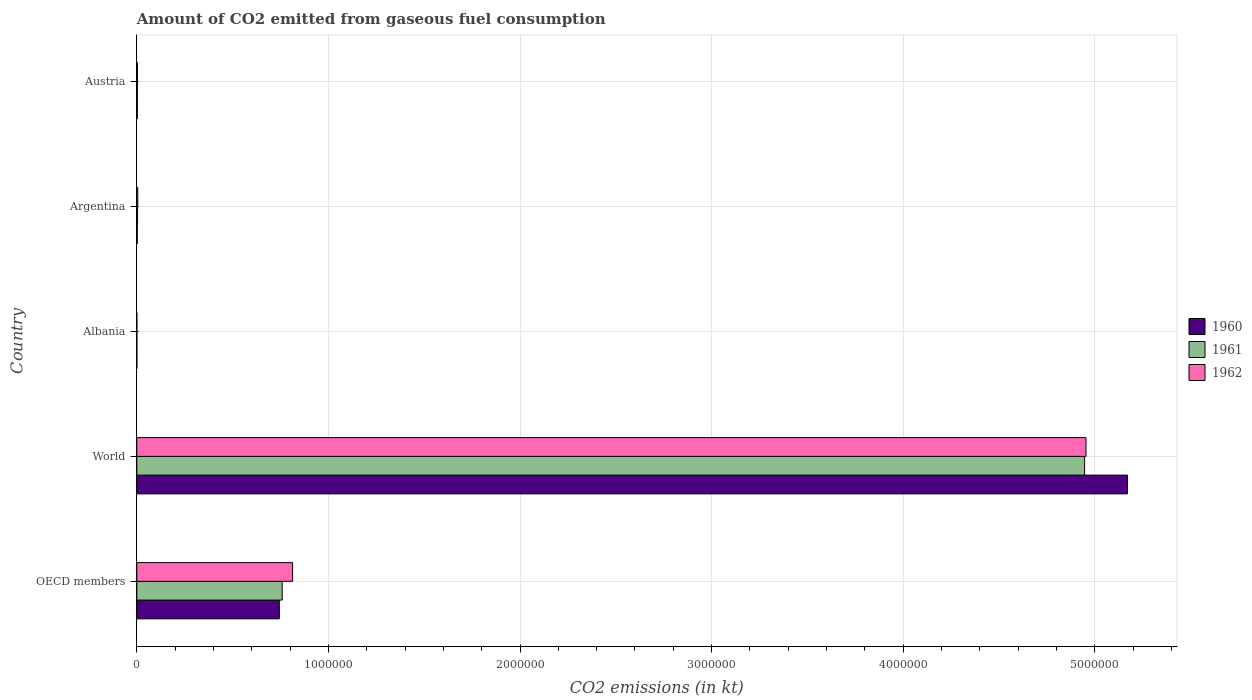Are the number of bars on each tick of the Y-axis equal?
Your answer should be very brief. Yes. In how many cases, is the number of bars for a given country not equal to the number of legend labels?
Your answer should be compact. 0. What is the amount of CO2 emitted in 1960 in Argentina?
Provide a short and direct response. 2365.22. Across all countries, what is the maximum amount of CO2 emitted in 1960?
Give a very brief answer. 5.17e+06. Across all countries, what is the minimum amount of CO2 emitted in 1961?
Your answer should be compact. 84.34. In which country was the amount of CO2 emitted in 1960 maximum?
Ensure brevity in your answer.  World. In which country was the amount of CO2 emitted in 1961 minimum?
Provide a succinct answer. Albania. What is the total amount of CO2 emitted in 1962 in the graph?
Offer a very short reply. 5.78e+06. What is the difference between the amount of CO2 emitted in 1962 in Argentina and that in Austria?
Provide a short and direct response. 1870.17. What is the difference between the amount of CO2 emitted in 1960 in Argentina and the amount of CO2 emitted in 1962 in Austria?
Keep it short and to the point. -876.41. What is the average amount of CO2 emitted in 1960 per country?
Provide a short and direct response. 1.18e+06. What is the difference between the amount of CO2 emitted in 1961 and amount of CO2 emitted in 1962 in Austria?
Your answer should be very brief. -150.35. What is the ratio of the amount of CO2 emitted in 1961 in Albania to that in Austria?
Give a very brief answer. 0.03. Is the amount of CO2 emitted in 1960 in Argentina less than that in World?
Ensure brevity in your answer.  Yes. What is the difference between the highest and the second highest amount of CO2 emitted in 1962?
Provide a succinct answer. 4.14e+06. What is the difference between the highest and the lowest amount of CO2 emitted in 1961?
Your response must be concise. 4.95e+06. What does the 1st bar from the top in World represents?
Make the answer very short. 1962. How many bars are there?
Your response must be concise. 15. Are all the bars in the graph horizontal?
Give a very brief answer. Yes. Are the values on the major ticks of X-axis written in scientific E-notation?
Offer a very short reply. No. Does the graph contain any zero values?
Give a very brief answer. No. Does the graph contain grids?
Offer a terse response. Yes. Where does the legend appear in the graph?
Ensure brevity in your answer.  Center right. How are the legend labels stacked?
Keep it short and to the point. Vertical. What is the title of the graph?
Ensure brevity in your answer.  Amount of CO2 emitted from gaseous fuel consumption. Does "1995" appear as one of the legend labels in the graph?
Ensure brevity in your answer.  No. What is the label or title of the X-axis?
Your response must be concise. CO2 emissions (in kt). What is the label or title of the Y-axis?
Provide a succinct answer. Country. What is the CO2 emissions (in kt) of 1960 in OECD members?
Offer a very short reply. 7.44e+05. What is the CO2 emissions (in kt) in 1961 in OECD members?
Provide a short and direct response. 7.59e+05. What is the CO2 emissions (in kt) in 1962 in OECD members?
Offer a terse response. 8.13e+05. What is the CO2 emissions (in kt) of 1960 in World?
Keep it short and to the point. 5.17e+06. What is the CO2 emissions (in kt) of 1961 in World?
Your answer should be compact. 4.95e+06. What is the CO2 emissions (in kt) of 1962 in World?
Make the answer very short. 4.95e+06. What is the CO2 emissions (in kt) of 1960 in Albania?
Your answer should be compact. 84.34. What is the CO2 emissions (in kt) in 1961 in Albania?
Keep it short and to the point. 84.34. What is the CO2 emissions (in kt) in 1962 in Albania?
Your answer should be very brief. 84.34. What is the CO2 emissions (in kt) of 1960 in Argentina?
Provide a short and direct response. 2365.22. What is the CO2 emissions (in kt) in 1961 in Argentina?
Your answer should be compact. 4033.7. What is the CO2 emissions (in kt) of 1962 in Argentina?
Your answer should be compact. 5111.8. What is the CO2 emissions (in kt) of 1960 in Austria?
Provide a short and direct response. 2922.6. What is the CO2 emissions (in kt) in 1961 in Austria?
Make the answer very short. 3091.28. What is the CO2 emissions (in kt) of 1962 in Austria?
Your answer should be very brief. 3241.63. Across all countries, what is the maximum CO2 emissions (in kt) of 1960?
Offer a very short reply. 5.17e+06. Across all countries, what is the maximum CO2 emissions (in kt) in 1961?
Make the answer very short. 4.95e+06. Across all countries, what is the maximum CO2 emissions (in kt) of 1962?
Offer a terse response. 4.95e+06. Across all countries, what is the minimum CO2 emissions (in kt) in 1960?
Your response must be concise. 84.34. Across all countries, what is the minimum CO2 emissions (in kt) in 1961?
Ensure brevity in your answer.  84.34. Across all countries, what is the minimum CO2 emissions (in kt) of 1962?
Your response must be concise. 84.34. What is the total CO2 emissions (in kt) in 1960 in the graph?
Give a very brief answer. 5.92e+06. What is the total CO2 emissions (in kt) of 1961 in the graph?
Give a very brief answer. 5.71e+06. What is the total CO2 emissions (in kt) in 1962 in the graph?
Give a very brief answer. 5.78e+06. What is the difference between the CO2 emissions (in kt) of 1960 in OECD members and that in World?
Ensure brevity in your answer.  -4.43e+06. What is the difference between the CO2 emissions (in kt) in 1961 in OECD members and that in World?
Make the answer very short. -4.19e+06. What is the difference between the CO2 emissions (in kt) in 1962 in OECD members and that in World?
Provide a short and direct response. -4.14e+06. What is the difference between the CO2 emissions (in kt) of 1960 in OECD members and that in Albania?
Offer a very short reply. 7.44e+05. What is the difference between the CO2 emissions (in kt) in 1961 in OECD members and that in Albania?
Provide a short and direct response. 7.59e+05. What is the difference between the CO2 emissions (in kt) in 1962 in OECD members and that in Albania?
Offer a very short reply. 8.13e+05. What is the difference between the CO2 emissions (in kt) in 1960 in OECD members and that in Argentina?
Your response must be concise. 7.42e+05. What is the difference between the CO2 emissions (in kt) in 1961 in OECD members and that in Argentina?
Give a very brief answer. 7.55e+05. What is the difference between the CO2 emissions (in kt) in 1962 in OECD members and that in Argentina?
Make the answer very short. 8.08e+05. What is the difference between the CO2 emissions (in kt) in 1960 in OECD members and that in Austria?
Provide a short and direct response. 7.41e+05. What is the difference between the CO2 emissions (in kt) in 1961 in OECD members and that in Austria?
Offer a very short reply. 7.56e+05. What is the difference between the CO2 emissions (in kt) of 1962 in OECD members and that in Austria?
Your answer should be compact. 8.10e+05. What is the difference between the CO2 emissions (in kt) in 1960 in World and that in Albania?
Provide a short and direct response. 5.17e+06. What is the difference between the CO2 emissions (in kt) in 1961 in World and that in Albania?
Offer a terse response. 4.95e+06. What is the difference between the CO2 emissions (in kt) of 1962 in World and that in Albania?
Provide a short and direct response. 4.95e+06. What is the difference between the CO2 emissions (in kt) in 1960 in World and that in Argentina?
Offer a very short reply. 5.17e+06. What is the difference between the CO2 emissions (in kt) of 1961 in World and that in Argentina?
Provide a short and direct response. 4.94e+06. What is the difference between the CO2 emissions (in kt) of 1962 in World and that in Argentina?
Your answer should be compact. 4.95e+06. What is the difference between the CO2 emissions (in kt) in 1960 in World and that in Austria?
Provide a succinct answer. 5.17e+06. What is the difference between the CO2 emissions (in kt) of 1961 in World and that in Austria?
Keep it short and to the point. 4.94e+06. What is the difference between the CO2 emissions (in kt) of 1962 in World and that in Austria?
Ensure brevity in your answer.  4.95e+06. What is the difference between the CO2 emissions (in kt) in 1960 in Albania and that in Argentina?
Provide a short and direct response. -2280.87. What is the difference between the CO2 emissions (in kt) of 1961 in Albania and that in Argentina?
Offer a very short reply. -3949.36. What is the difference between the CO2 emissions (in kt) in 1962 in Albania and that in Argentina?
Make the answer very short. -5027.46. What is the difference between the CO2 emissions (in kt) in 1960 in Albania and that in Austria?
Give a very brief answer. -2838.26. What is the difference between the CO2 emissions (in kt) of 1961 in Albania and that in Austria?
Your response must be concise. -3006.94. What is the difference between the CO2 emissions (in kt) of 1962 in Albania and that in Austria?
Your response must be concise. -3157.29. What is the difference between the CO2 emissions (in kt) of 1960 in Argentina and that in Austria?
Provide a short and direct response. -557.38. What is the difference between the CO2 emissions (in kt) of 1961 in Argentina and that in Austria?
Offer a very short reply. 942.42. What is the difference between the CO2 emissions (in kt) in 1962 in Argentina and that in Austria?
Keep it short and to the point. 1870.17. What is the difference between the CO2 emissions (in kt) in 1960 in OECD members and the CO2 emissions (in kt) in 1961 in World?
Offer a very short reply. -4.20e+06. What is the difference between the CO2 emissions (in kt) of 1960 in OECD members and the CO2 emissions (in kt) of 1962 in World?
Offer a terse response. -4.21e+06. What is the difference between the CO2 emissions (in kt) in 1961 in OECD members and the CO2 emissions (in kt) in 1962 in World?
Make the answer very short. -4.20e+06. What is the difference between the CO2 emissions (in kt) of 1960 in OECD members and the CO2 emissions (in kt) of 1961 in Albania?
Offer a terse response. 7.44e+05. What is the difference between the CO2 emissions (in kt) in 1960 in OECD members and the CO2 emissions (in kt) in 1962 in Albania?
Your answer should be very brief. 7.44e+05. What is the difference between the CO2 emissions (in kt) in 1961 in OECD members and the CO2 emissions (in kt) in 1962 in Albania?
Make the answer very short. 7.59e+05. What is the difference between the CO2 emissions (in kt) of 1960 in OECD members and the CO2 emissions (in kt) of 1961 in Argentina?
Provide a succinct answer. 7.40e+05. What is the difference between the CO2 emissions (in kt) of 1960 in OECD members and the CO2 emissions (in kt) of 1962 in Argentina?
Provide a succinct answer. 7.39e+05. What is the difference between the CO2 emissions (in kt) in 1961 in OECD members and the CO2 emissions (in kt) in 1962 in Argentina?
Keep it short and to the point. 7.54e+05. What is the difference between the CO2 emissions (in kt) of 1960 in OECD members and the CO2 emissions (in kt) of 1961 in Austria?
Your answer should be very brief. 7.41e+05. What is the difference between the CO2 emissions (in kt) in 1960 in OECD members and the CO2 emissions (in kt) in 1962 in Austria?
Give a very brief answer. 7.41e+05. What is the difference between the CO2 emissions (in kt) in 1961 in OECD members and the CO2 emissions (in kt) in 1962 in Austria?
Provide a succinct answer. 7.56e+05. What is the difference between the CO2 emissions (in kt) in 1960 in World and the CO2 emissions (in kt) in 1961 in Albania?
Your answer should be compact. 5.17e+06. What is the difference between the CO2 emissions (in kt) in 1960 in World and the CO2 emissions (in kt) in 1962 in Albania?
Provide a short and direct response. 5.17e+06. What is the difference between the CO2 emissions (in kt) of 1961 in World and the CO2 emissions (in kt) of 1962 in Albania?
Your answer should be compact. 4.95e+06. What is the difference between the CO2 emissions (in kt) of 1960 in World and the CO2 emissions (in kt) of 1961 in Argentina?
Your response must be concise. 5.17e+06. What is the difference between the CO2 emissions (in kt) of 1960 in World and the CO2 emissions (in kt) of 1962 in Argentina?
Your answer should be very brief. 5.17e+06. What is the difference between the CO2 emissions (in kt) in 1961 in World and the CO2 emissions (in kt) in 1962 in Argentina?
Keep it short and to the point. 4.94e+06. What is the difference between the CO2 emissions (in kt) of 1960 in World and the CO2 emissions (in kt) of 1961 in Austria?
Ensure brevity in your answer.  5.17e+06. What is the difference between the CO2 emissions (in kt) of 1960 in World and the CO2 emissions (in kt) of 1962 in Austria?
Give a very brief answer. 5.17e+06. What is the difference between the CO2 emissions (in kt) in 1961 in World and the CO2 emissions (in kt) in 1962 in Austria?
Offer a terse response. 4.94e+06. What is the difference between the CO2 emissions (in kt) of 1960 in Albania and the CO2 emissions (in kt) of 1961 in Argentina?
Your answer should be compact. -3949.36. What is the difference between the CO2 emissions (in kt) in 1960 in Albania and the CO2 emissions (in kt) in 1962 in Argentina?
Offer a terse response. -5027.46. What is the difference between the CO2 emissions (in kt) in 1961 in Albania and the CO2 emissions (in kt) in 1962 in Argentina?
Your answer should be compact. -5027.46. What is the difference between the CO2 emissions (in kt) of 1960 in Albania and the CO2 emissions (in kt) of 1961 in Austria?
Offer a terse response. -3006.94. What is the difference between the CO2 emissions (in kt) in 1960 in Albania and the CO2 emissions (in kt) in 1962 in Austria?
Provide a succinct answer. -3157.29. What is the difference between the CO2 emissions (in kt) in 1961 in Albania and the CO2 emissions (in kt) in 1962 in Austria?
Your response must be concise. -3157.29. What is the difference between the CO2 emissions (in kt) of 1960 in Argentina and the CO2 emissions (in kt) of 1961 in Austria?
Offer a very short reply. -726.07. What is the difference between the CO2 emissions (in kt) in 1960 in Argentina and the CO2 emissions (in kt) in 1962 in Austria?
Make the answer very short. -876.41. What is the difference between the CO2 emissions (in kt) of 1961 in Argentina and the CO2 emissions (in kt) of 1962 in Austria?
Give a very brief answer. 792.07. What is the average CO2 emissions (in kt) of 1960 per country?
Offer a very short reply. 1.18e+06. What is the average CO2 emissions (in kt) in 1961 per country?
Provide a succinct answer. 1.14e+06. What is the average CO2 emissions (in kt) in 1962 per country?
Offer a very short reply. 1.16e+06. What is the difference between the CO2 emissions (in kt) in 1960 and CO2 emissions (in kt) in 1961 in OECD members?
Provide a short and direct response. -1.48e+04. What is the difference between the CO2 emissions (in kt) of 1960 and CO2 emissions (in kt) of 1962 in OECD members?
Your response must be concise. -6.92e+04. What is the difference between the CO2 emissions (in kt) in 1961 and CO2 emissions (in kt) in 1962 in OECD members?
Make the answer very short. -5.44e+04. What is the difference between the CO2 emissions (in kt) of 1960 and CO2 emissions (in kt) of 1961 in World?
Offer a terse response. 2.24e+05. What is the difference between the CO2 emissions (in kt) in 1960 and CO2 emissions (in kt) in 1962 in World?
Provide a short and direct response. 2.16e+05. What is the difference between the CO2 emissions (in kt) of 1961 and CO2 emissions (in kt) of 1962 in World?
Offer a terse response. -7334. What is the difference between the CO2 emissions (in kt) in 1961 and CO2 emissions (in kt) in 1962 in Albania?
Give a very brief answer. 0. What is the difference between the CO2 emissions (in kt) in 1960 and CO2 emissions (in kt) in 1961 in Argentina?
Your answer should be very brief. -1668.48. What is the difference between the CO2 emissions (in kt) of 1960 and CO2 emissions (in kt) of 1962 in Argentina?
Make the answer very short. -2746.58. What is the difference between the CO2 emissions (in kt) of 1961 and CO2 emissions (in kt) of 1962 in Argentina?
Your answer should be compact. -1078.1. What is the difference between the CO2 emissions (in kt) in 1960 and CO2 emissions (in kt) in 1961 in Austria?
Provide a succinct answer. -168.68. What is the difference between the CO2 emissions (in kt) of 1960 and CO2 emissions (in kt) of 1962 in Austria?
Offer a very short reply. -319.03. What is the difference between the CO2 emissions (in kt) of 1961 and CO2 emissions (in kt) of 1962 in Austria?
Your answer should be very brief. -150.35. What is the ratio of the CO2 emissions (in kt) in 1960 in OECD members to that in World?
Give a very brief answer. 0.14. What is the ratio of the CO2 emissions (in kt) of 1961 in OECD members to that in World?
Make the answer very short. 0.15. What is the ratio of the CO2 emissions (in kt) in 1962 in OECD members to that in World?
Provide a short and direct response. 0.16. What is the ratio of the CO2 emissions (in kt) of 1960 in OECD members to that in Albania?
Give a very brief answer. 8821.78. What is the ratio of the CO2 emissions (in kt) in 1961 in OECD members to that in Albania?
Provide a short and direct response. 8997.23. What is the ratio of the CO2 emissions (in kt) of 1962 in OECD members to that in Albania?
Keep it short and to the point. 9641.88. What is the ratio of the CO2 emissions (in kt) in 1960 in OECD members to that in Argentina?
Provide a succinct answer. 314.57. What is the ratio of the CO2 emissions (in kt) in 1961 in OECD members to that in Argentina?
Offer a very short reply. 188.12. What is the ratio of the CO2 emissions (in kt) of 1962 in OECD members to that in Argentina?
Offer a very short reply. 159.08. What is the ratio of the CO2 emissions (in kt) in 1960 in OECD members to that in Austria?
Provide a succinct answer. 254.58. What is the ratio of the CO2 emissions (in kt) in 1961 in OECD members to that in Austria?
Offer a terse response. 245.48. What is the ratio of the CO2 emissions (in kt) in 1962 in OECD members to that in Austria?
Offer a terse response. 250.86. What is the ratio of the CO2 emissions (in kt) of 1960 in World to that in Albania?
Your response must be concise. 6.13e+04. What is the ratio of the CO2 emissions (in kt) in 1961 in World to that in Albania?
Ensure brevity in your answer.  5.87e+04. What is the ratio of the CO2 emissions (in kt) in 1962 in World to that in Albania?
Give a very brief answer. 5.87e+04. What is the ratio of the CO2 emissions (in kt) in 1960 in World to that in Argentina?
Offer a very short reply. 2186.05. What is the ratio of the CO2 emissions (in kt) of 1961 in World to that in Argentina?
Offer a terse response. 1226.36. What is the ratio of the CO2 emissions (in kt) in 1962 in World to that in Argentina?
Your answer should be very brief. 969.15. What is the ratio of the CO2 emissions (in kt) in 1960 in World to that in Austria?
Provide a short and direct response. 1769.13. What is the ratio of the CO2 emissions (in kt) in 1961 in World to that in Austria?
Your answer should be compact. 1600.24. What is the ratio of the CO2 emissions (in kt) of 1962 in World to that in Austria?
Provide a short and direct response. 1528.28. What is the ratio of the CO2 emissions (in kt) of 1960 in Albania to that in Argentina?
Provide a short and direct response. 0.04. What is the ratio of the CO2 emissions (in kt) of 1961 in Albania to that in Argentina?
Your answer should be very brief. 0.02. What is the ratio of the CO2 emissions (in kt) of 1962 in Albania to that in Argentina?
Make the answer very short. 0.02. What is the ratio of the CO2 emissions (in kt) of 1960 in Albania to that in Austria?
Give a very brief answer. 0.03. What is the ratio of the CO2 emissions (in kt) in 1961 in Albania to that in Austria?
Your response must be concise. 0.03. What is the ratio of the CO2 emissions (in kt) in 1962 in Albania to that in Austria?
Keep it short and to the point. 0.03. What is the ratio of the CO2 emissions (in kt) in 1960 in Argentina to that in Austria?
Provide a short and direct response. 0.81. What is the ratio of the CO2 emissions (in kt) of 1961 in Argentina to that in Austria?
Your response must be concise. 1.3. What is the ratio of the CO2 emissions (in kt) in 1962 in Argentina to that in Austria?
Ensure brevity in your answer.  1.58. What is the difference between the highest and the second highest CO2 emissions (in kt) of 1960?
Offer a terse response. 4.43e+06. What is the difference between the highest and the second highest CO2 emissions (in kt) in 1961?
Provide a succinct answer. 4.19e+06. What is the difference between the highest and the second highest CO2 emissions (in kt) of 1962?
Give a very brief answer. 4.14e+06. What is the difference between the highest and the lowest CO2 emissions (in kt) in 1960?
Provide a succinct answer. 5.17e+06. What is the difference between the highest and the lowest CO2 emissions (in kt) of 1961?
Provide a succinct answer. 4.95e+06. What is the difference between the highest and the lowest CO2 emissions (in kt) in 1962?
Offer a very short reply. 4.95e+06. 